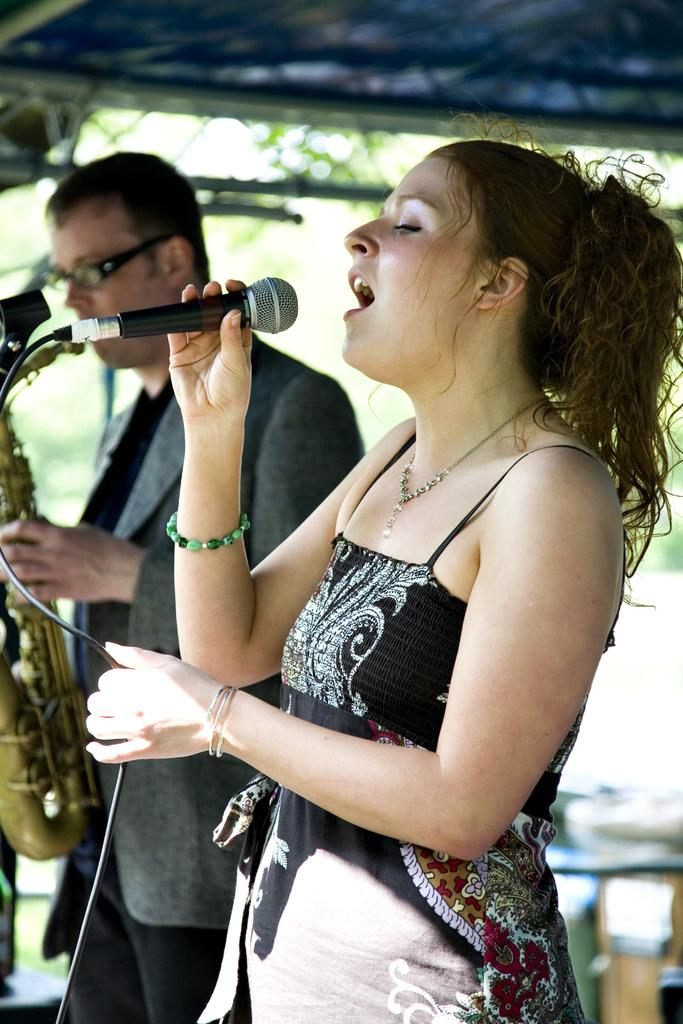Who is the main subject in the image? There is a lady in the image. What is the lady doing in the image? The lady is singing a song and holding a mic. Are there any other people in the image? Yes, there is a guy in the image. What is the guy doing in the image? The guy is playing a saxophone. What type of cabbage can be seen growing in the background of the image? There is no cabbage present in the image; it features a lady singing and a guy playing a saxophone. 